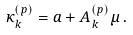<formula> <loc_0><loc_0><loc_500><loc_500>\kappa _ { k } ^ { ( p ) } = a + A _ { k } ^ { ( p ) } \mu \, .</formula> 